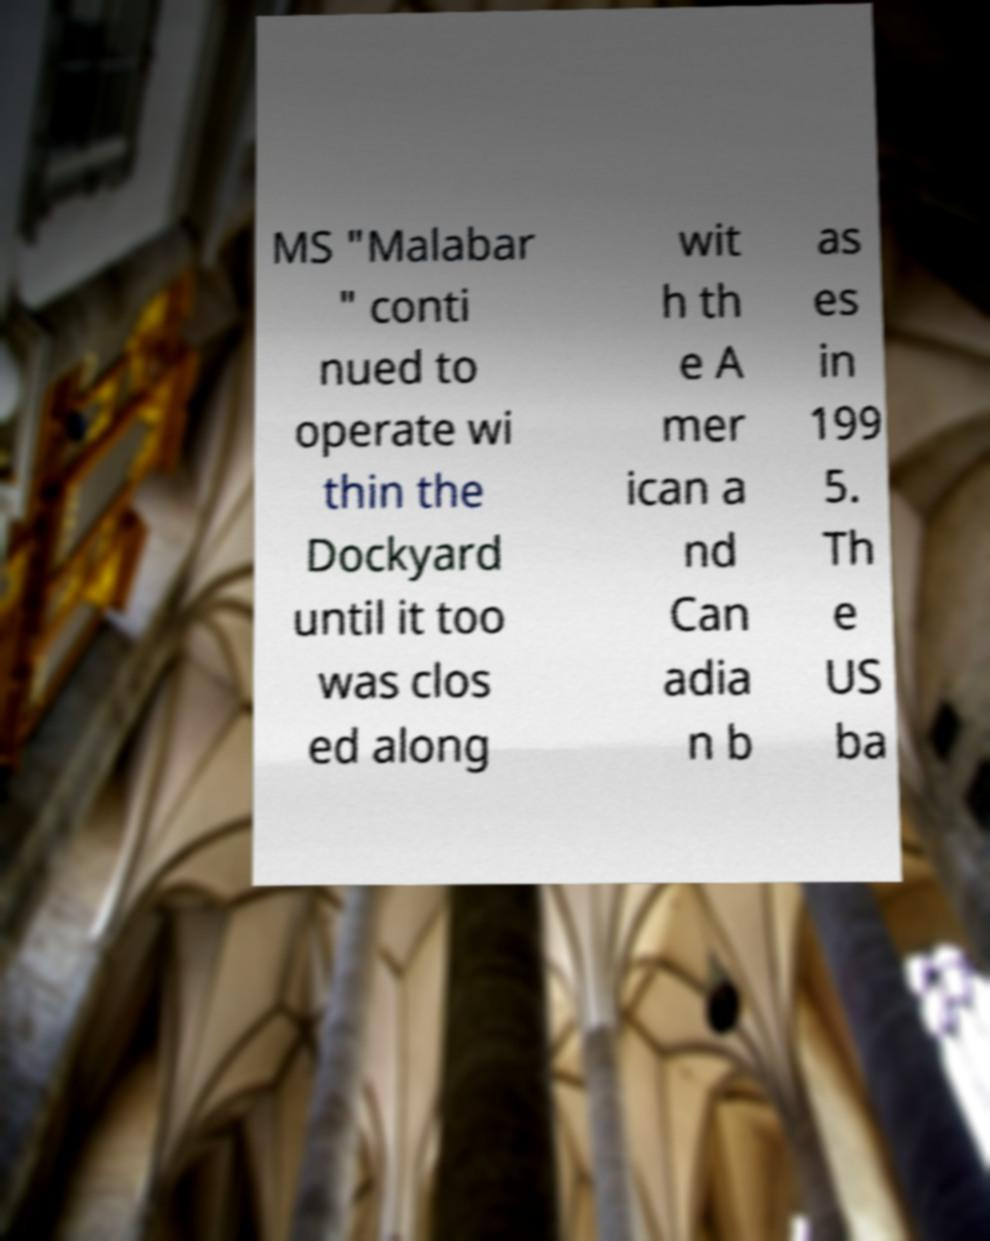Can you read and provide the text displayed in the image?This photo seems to have some interesting text. Can you extract and type it out for me? MS "Malabar " conti nued to operate wi thin the Dockyard until it too was clos ed along wit h th e A mer ican a nd Can adia n b as es in 199 5. Th e US ba 